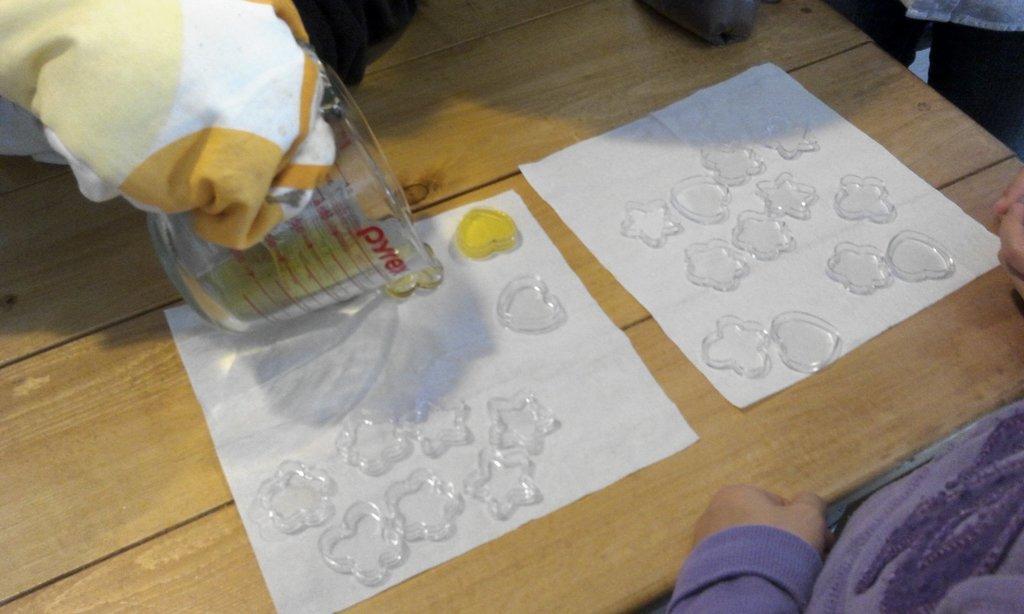Describe this image in one or two sentences. In this picture I can observe wooden table. In the middle of the picture I can observe some plastic objects placed on the white color papers. These papers are on the table. On the left side I can observe jar. 